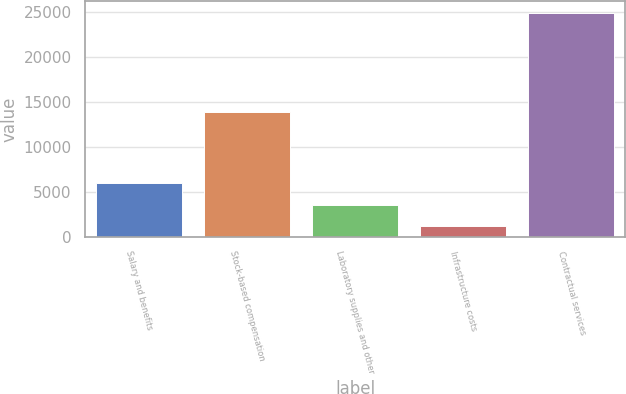<chart> <loc_0><loc_0><loc_500><loc_500><bar_chart><fcel>Salary and benefits<fcel>Stock-based compensation<fcel>Laboratory supplies and other<fcel>Infrastructure costs<fcel>Contractual services<nl><fcel>5946.8<fcel>13900<fcel>3570.4<fcel>1194<fcel>24958<nl></chart> 